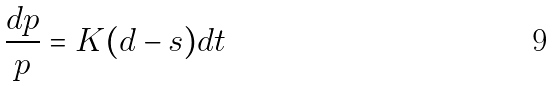<formula> <loc_0><loc_0><loc_500><loc_500>\frac { d p } { p } = K ( d - s ) d t</formula> 